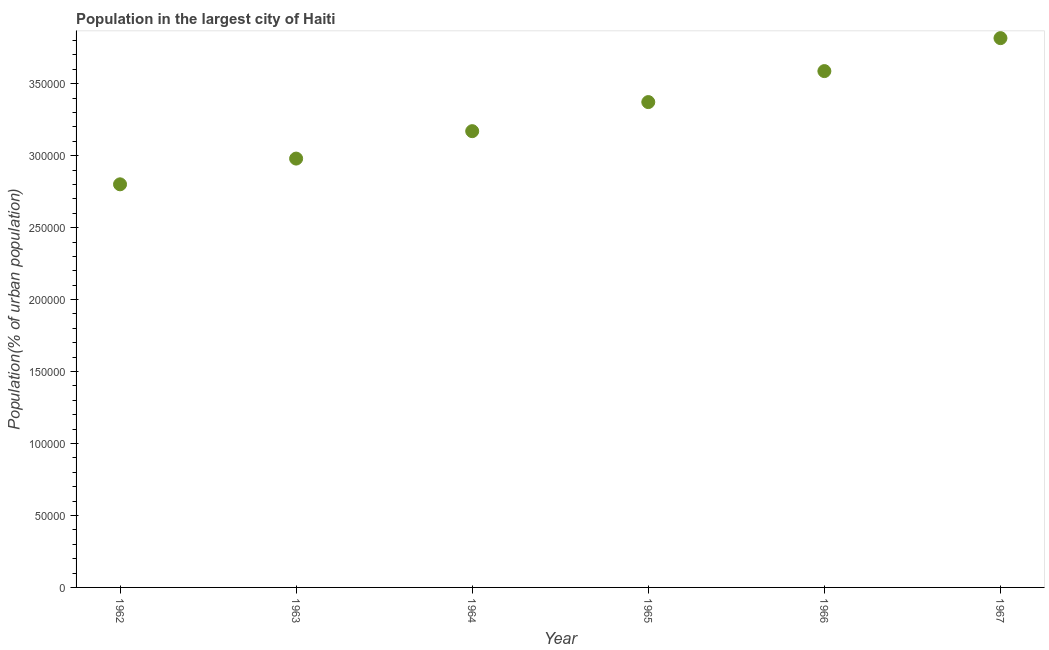What is the population in largest city in 1965?
Keep it short and to the point. 3.37e+05. Across all years, what is the maximum population in largest city?
Give a very brief answer. 3.82e+05. Across all years, what is the minimum population in largest city?
Your response must be concise. 2.80e+05. In which year was the population in largest city maximum?
Give a very brief answer. 1967. In which year was the population in largest city minimum?
Your answer should be compact. 1962. What is the sum of the population in largest city?
Give a very brief answer. 1.97e+06. What is the difference between the population in largest city in 1964 and 1967?
Ensure brevity in your answer.  -6.46e+04. What is the average population in largest city per year?
Your response must be concise. 3.29e+05. What is the median population in largest city?
Offer a terse response. 3.27e+05. What is the ratio of the population in largest city in 1965 to that in 1966?
Keep it short and to the point. 0.94. Is the difference between the population in largest city in 1962 and 1963 greater than the difference between any two years?
Offer a very short reply. No. What is the difference between the highest and the second highest population in largest city?
Keep it short and to the point. 2.29e+04. Is the sum of the population in largest city in 1962 and 1966 greater than the maximum population in largest city across all years?
Provide a short and direct response. Yes. What is the difference between the highest and the lowest population in largest city?
Give a very brief answer. 1.02e+05. In how many years, is the population in largest city greater than the average population in largest city taken over all years?
Ensure brevity in your answer.  3. Does the population in largest city monotonically increase over the years?
Provide a short and direct response. Yes. How many dotlines are there?
Keep it short and to the point. 1. What is the title of the graph?
Ensure brevity in your answer.  Population in the largest city of Haiti. What is the label or title of the X-axis?
Provide a succinct answer. Year. What is the label or title of the Y-axis?
Give a very brief answer. Population(% of urban population). What is the Population(% of urban population) in 1962?
Offer a terse response. 2.80e+05. What is the Population(% of urban population) in 1963?
Make the answer very short. 2.98e+05. What is the Population(% of urban population) in 1964?
Give a very brief answer. 3.17e+05. What is the Population(% of urban population) in 1965?
Provide a short and direct response. 3.37e+05. What is the Population(% of urban population) in 1966?
Make the answer very short. 3.59e+05. What is the Population(% of urban population) in 1967?
Make the answer very short. 3.82e+05. What is the difference between the Population(% of urban population) in 1962 and 1963?
Provide a succinct answer. -1.79e+04. What is the difference between the Population(% of urban population) in 1962 and 1964?
Provide a succinct answer. -3.69e+04. What is the difference between the Population(% of urban population) in 1962 and 1965?
Your response must be concise. -5.71e+04. What is the difference between the Population(% of urban population) in 1962 and 1966?
Give a very brief answer. -7.87e+04. What is the difference between the Population(% of urban population) in 1962 and 1967?
Offer a very short reply. -1.02e+05. What is the difference between the Population(% of urban population) in 1963 and 1964?
Keep it short and to the point. -1.90e+04. What is the difference between the Population(% of urban population) in 1963 and 1965?
Your response must be concise. -3.93e+04. What is the difference between the Population(% of urban population) in 1963 and 1966?
Give a very brief answer. -6.08e+04. What is the difference between the Population(% of urban population) in 1963 and 1967?
Offer a very short reply. -8.37e+04. What is the difference between the Population(% of urban population) in 1964 and 1965?
Keep it short and to the point. -2.02e+04. What is the difference between the Population(% of urban population) in 1964 and 1966?
Give a very brief answer. -4.17e+04. What is the difference between the Population(% of urban population) in 1964 and 1967?
Offer a very short reply. -6.46e+04. What is the difference between the Population(% of urban population) in 1965 and 1966?
Make the answer very short. -2.15e+04. What is the difference between the Population(% of urban population) in 1965 and 1967?
Your answer should be very brief. -4.44e+04. What is the difference between the Population(% of urban population) in 1966 and 1967?
Offer a terse response. -2.29e+04. What is the ratio of the Population(% of urban population) in 1962 to that in 1964?
Provide a succinct answer. 0.88. What is the ratio of the Population(% of urban population) in 1962 to that in 1965?
Your answer should be compact. 0.83. What is the ratio of the Population(% of urban population) in 1962 to that in 1966?
Provide a short and direct response. 0.78. What is the ratio of the Population(% of urban population) in 1962 to that in 1967?
Keep it short and to the point. 0.73. What is the ratio of the Population(% of urban population) in 1963 to that in 1964?
Your answer should be compact. 0.94. What is the ratio of the Population(% of urban population) in 1963 to that in 1965?
Your answer should be very brief. 0.88. What is the ratio of the Population(% of urban population) in 1963 to that in 1966?
Give a very brief answer. 0.83. What is the ratio of the Population(% of urban population) in 1963 to that in 1967?
Ensure brevity in your answer.  0.78. What is the ratio of the Population(% of urban population) in 1964 to that in 1966?
Your response must be concise. 0.88. What is the ratio of the Population(% of urban population) in 1964 to that in 1967?
Make the answer very short. 0.83. What is the ratio of the Population(% of urban population) in 1965 to that in 1967?
Provide a short and direct response. 0.88. What is the ratio of the Population(% of urban population) in 1966 to that in 1967?
Make the answer very short. 0.94. 